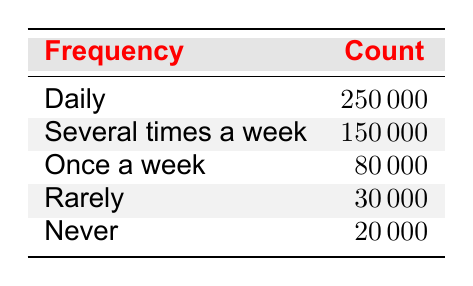What is the total number of Ontario residents working remotely daily? The table indicates that 250000 residents reported working remotely daily.
Answer: 250000 How many residents work remotely several times a week? According to the table, the count for "Several times a week" is 150000 residents.
Answer: 150000 What is the combined frequency of remote work occurrences for 'Once a week' and 'Rarely'? The count for "Once a week" is 80000 and for "Rarely" it is 30000. Adding them gives 80000 + 30000 = 110000 for the combined total.
Answer: 110000 Is it true that more residents work remotely daily than those who never work remotely? The table shows 250000 residents work remotely daily, while only 20000 never work remotely. Since 250000 is greater than 20000, the statement is true.
Answer: Yes What percentage of residents work remotely 'Rarely' compared to those who work 'Daily'? The count for "Rarely" is 30000 and for "Daily" is 250000. To find the percentage: (30000 / 250000) * 100 = 12%.
Answer: 12% If we combine the counts for 'Daily' and 'Several times a week', what proportion of residents work remotely at least a few times a week? The counts are 250000 for "Daily" and 150000 for "Several times a week", so adding these gives 250000 + 150000 = 400000. The total remote work count is 250000 + 150000 + 80000 + 30000 + 20000 = 580000. Hence, the proportion is 400000 / 580000 ≈ 0.6897 or 68.97%.
Answer: Approximately 68.97% What is the difference in count between those working 'Once a week' and those working 'Never'? The count for "Once a week" is 80000 while "Never" is 20000. The difference is calculated as 80000 - 20000 = 60000.
Answer: 60000 How many residents report doing remote work at least once a week? By examining the counts: "Daily" (250000), "Several times a week" (150000), and "Once a week" (80000), we add these values together: 250000 + 150000 + 80000 = 480000.
Answer: 480000 